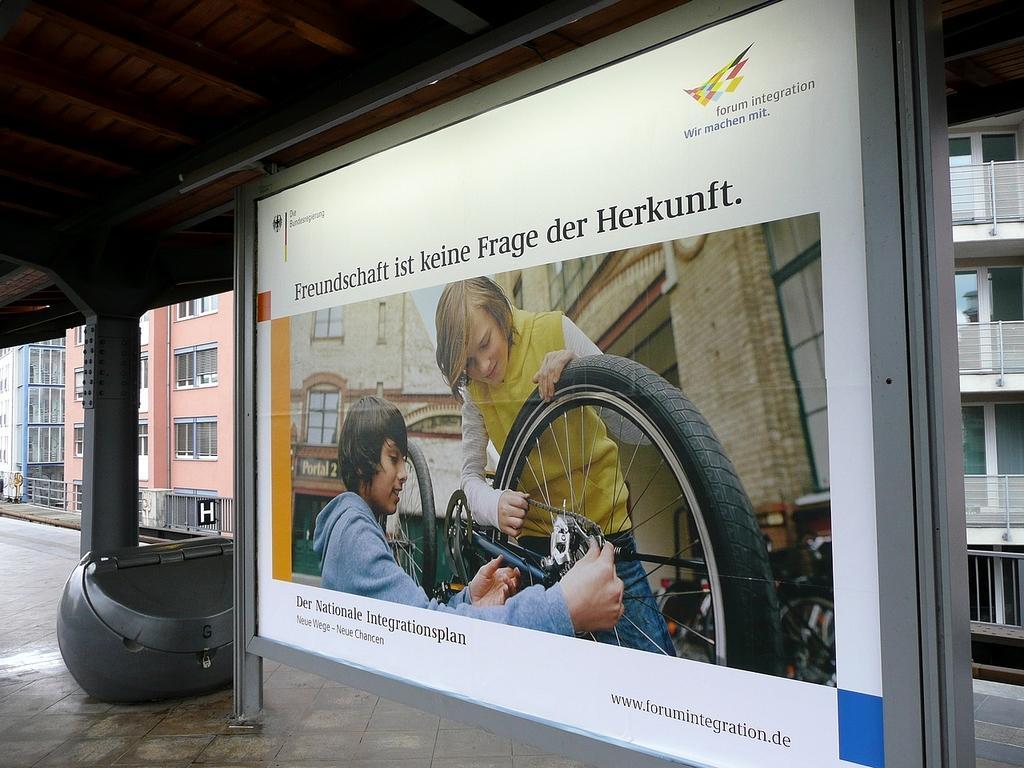How would you summarize this image in a sentence or two? In front of the image there is a display board with an advertisement on it, beside the display board there is some object and there are pillars, at the top of the image there is a wooden rooftop, in the background of the image there are buildings, metal rod fence and metal rod balconies and glass windows. 